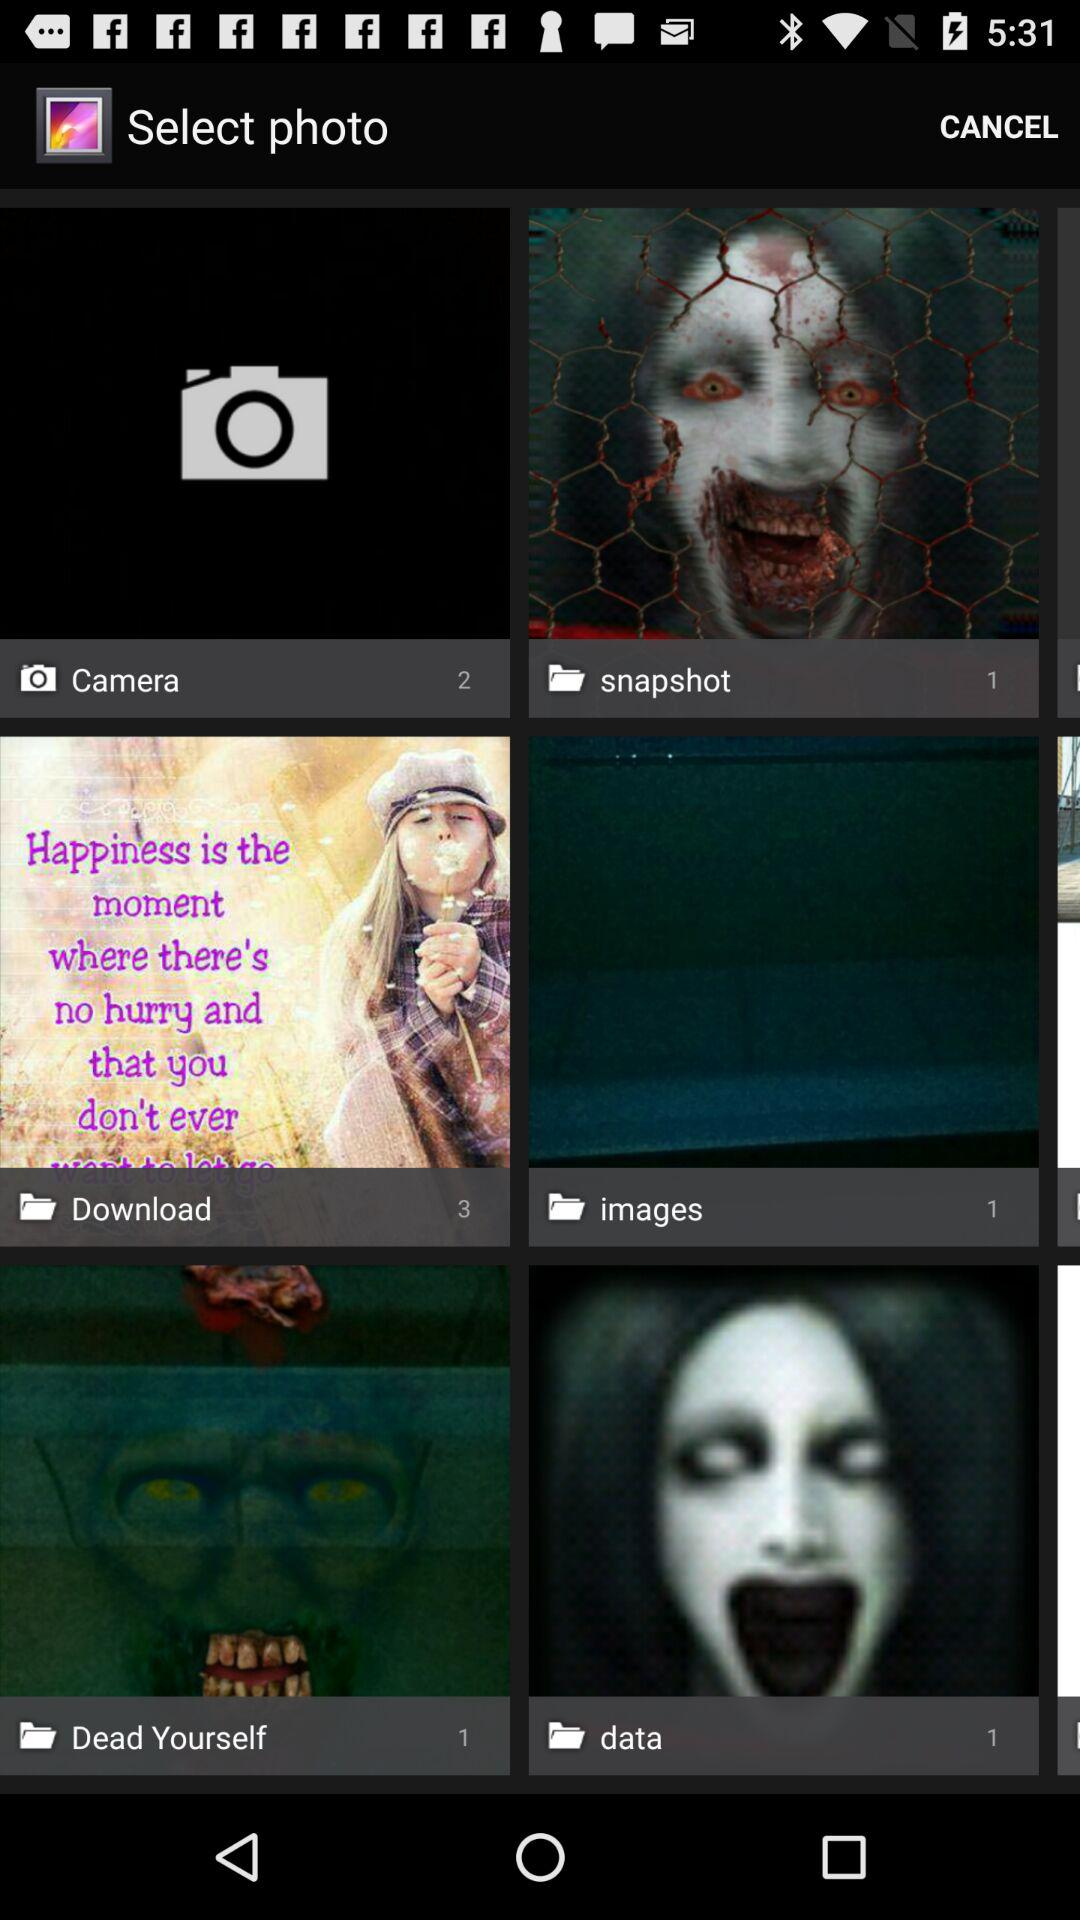How many photos are there in the "Download" folder? There are 3 photos in the "Download" folder. 